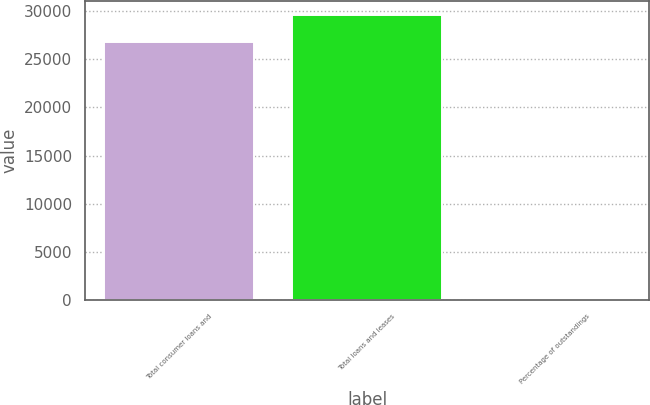Convert chart. <chart><loc_0><loc_0><loc_500><loc_500><bar_chart><fcel>Total consumer loans and<fcel>Total loans and leases<fcel>Percentage of outstandings<nl><fcel>26750<fcel>29591.8<fcel>3.22<nl></chart> 